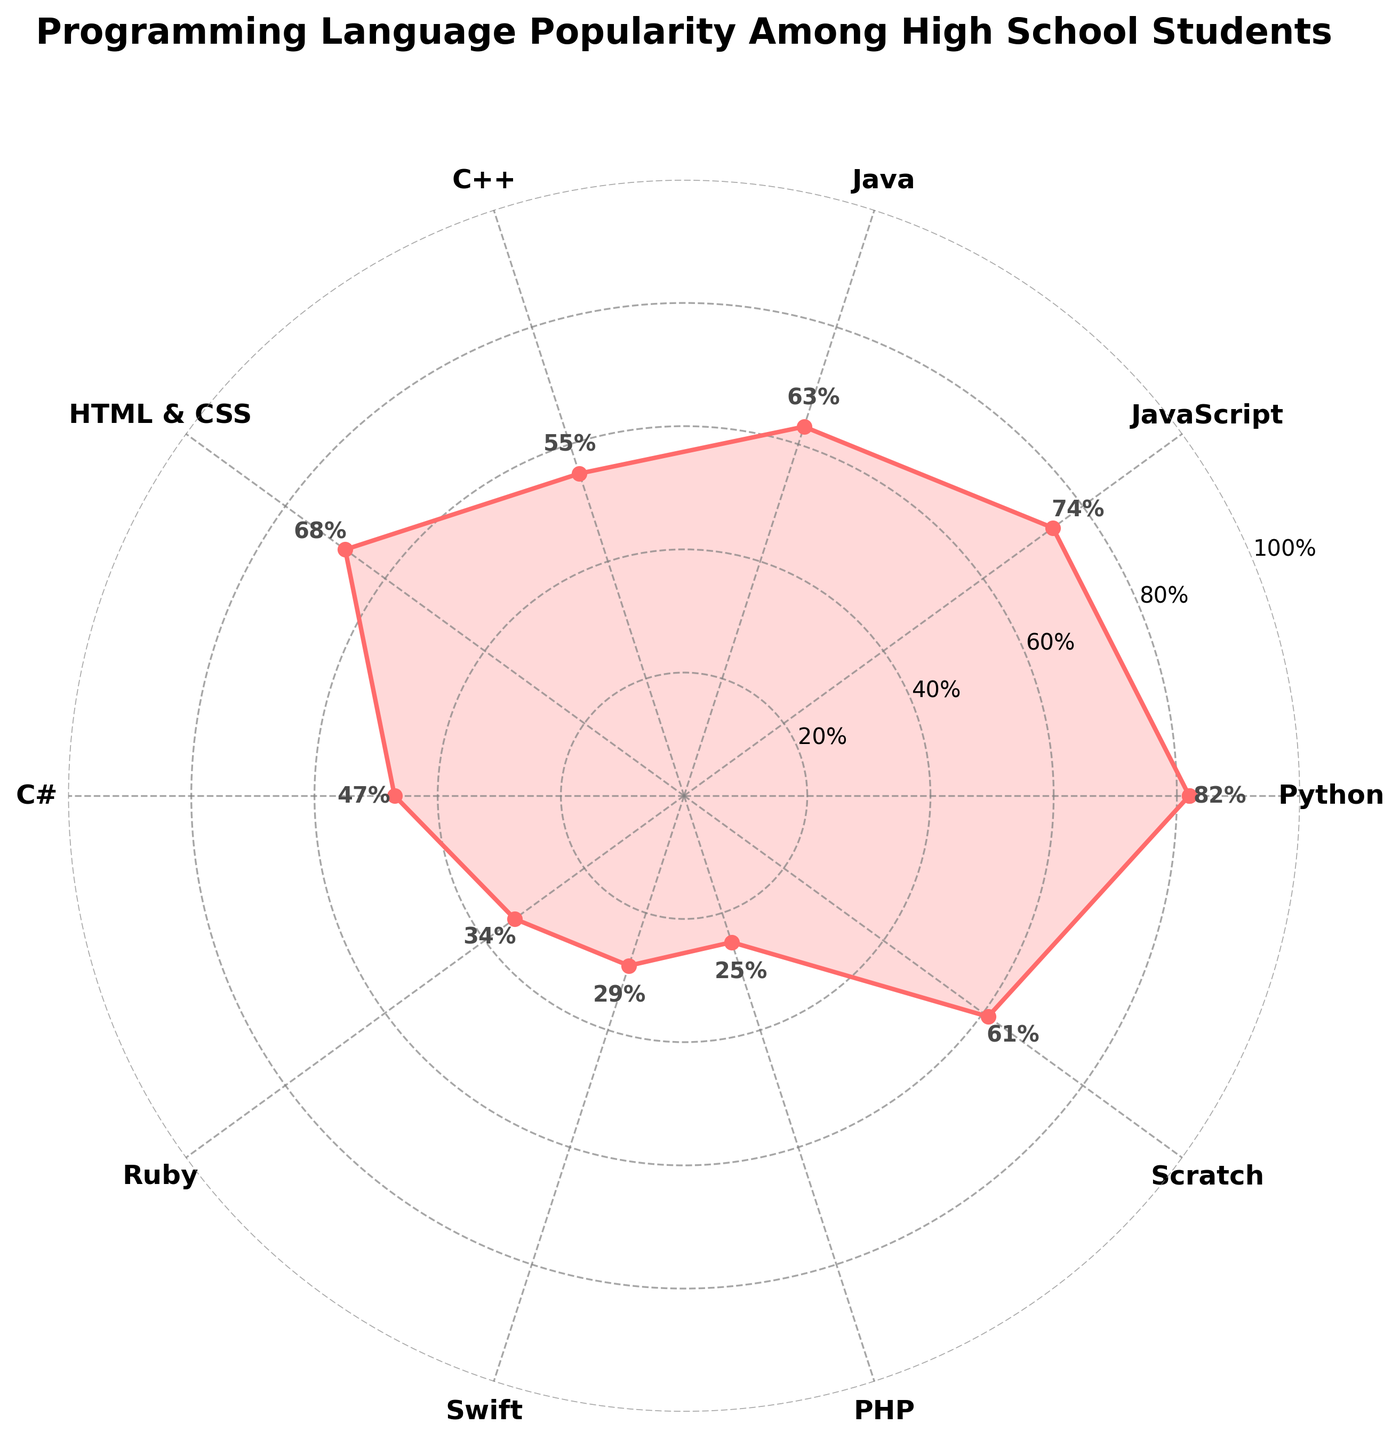what is the title of the chart? The title is usually displayed at the top of the chart. In this case, it reads "Programming Language Popularity Among High School Students."
Answer: Programming Language Popularity Among High School Students which languages have a popularity above 60%? To find this, look for the data points that exceed the 60% mark on the y-axis. These languages are Python, JavaScript, HTML & CSS, Java, and Scratch.
Answer: Python, JavaScript, HTML & CSS, Java, Scratch what is the angle corresponding to the JavaScript data point? JavaScript is the second data point. The full circle is 360 degrees, and there are 10 data points. The angle for the second data point is 360/10 * 1 = 36 degrees.
Answer: 36 degrees which programming language has the lowest popularity? Look for the data point with the lowest value on the radar chart. This is the programming language PHP with a popularity of 25%.
Answer: PHP how much more popular is Python compared to PHP? Find the popularity values for Python (82%) and PHP (25%), then subtract PHP’s value from Python’s value: 82% - 25% = 57%.
Answer: 57% what is the sum of the popularity values for all programming languages? Add all the values given: 82 + 74 + 63 + 55 + 68 + 47 + 34 + 29 + 25 + 61 = 538.
Answer: 538 how many languages have a popularity between 30% and 50%? Check the radar chart for data points that fall between the 30% and 50% range. These languages are C#, Ruby, and Swift.
Answer: 3 which has higher popularity: JavaScript or Java? Compare the data points for JavaScript (74%) and Java (63%). JavaScript has a higher popularity.
Answer: JavaScript what is the average popularity among all listed programming languages? Add all popularity values and divide by the number of programming languages: (82 + 74 + 63 + 55 + 68 + 47 + 34 + 29 + 25 + 61) / 10 = 53.8%.
Answer: 53.8% which programming language has the closest popularity to the median value? Arrange all values in ascending order: 25, 29, 34, 47, 55, 61, 63, 68, 74, 82. The median values are the 5th and 6th, which are 55 and 61. The closest value to their average (58%) is 61%, attributed to Scratch.
Answer: Scratch 